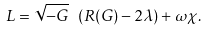Convert formula to latex. <formula><loc_0><loc_0><loc_500><loc_500>L = \sqrt { - G } \ ( R ( G ) - 2 \lambda ) + \omega \chi .</formula> 